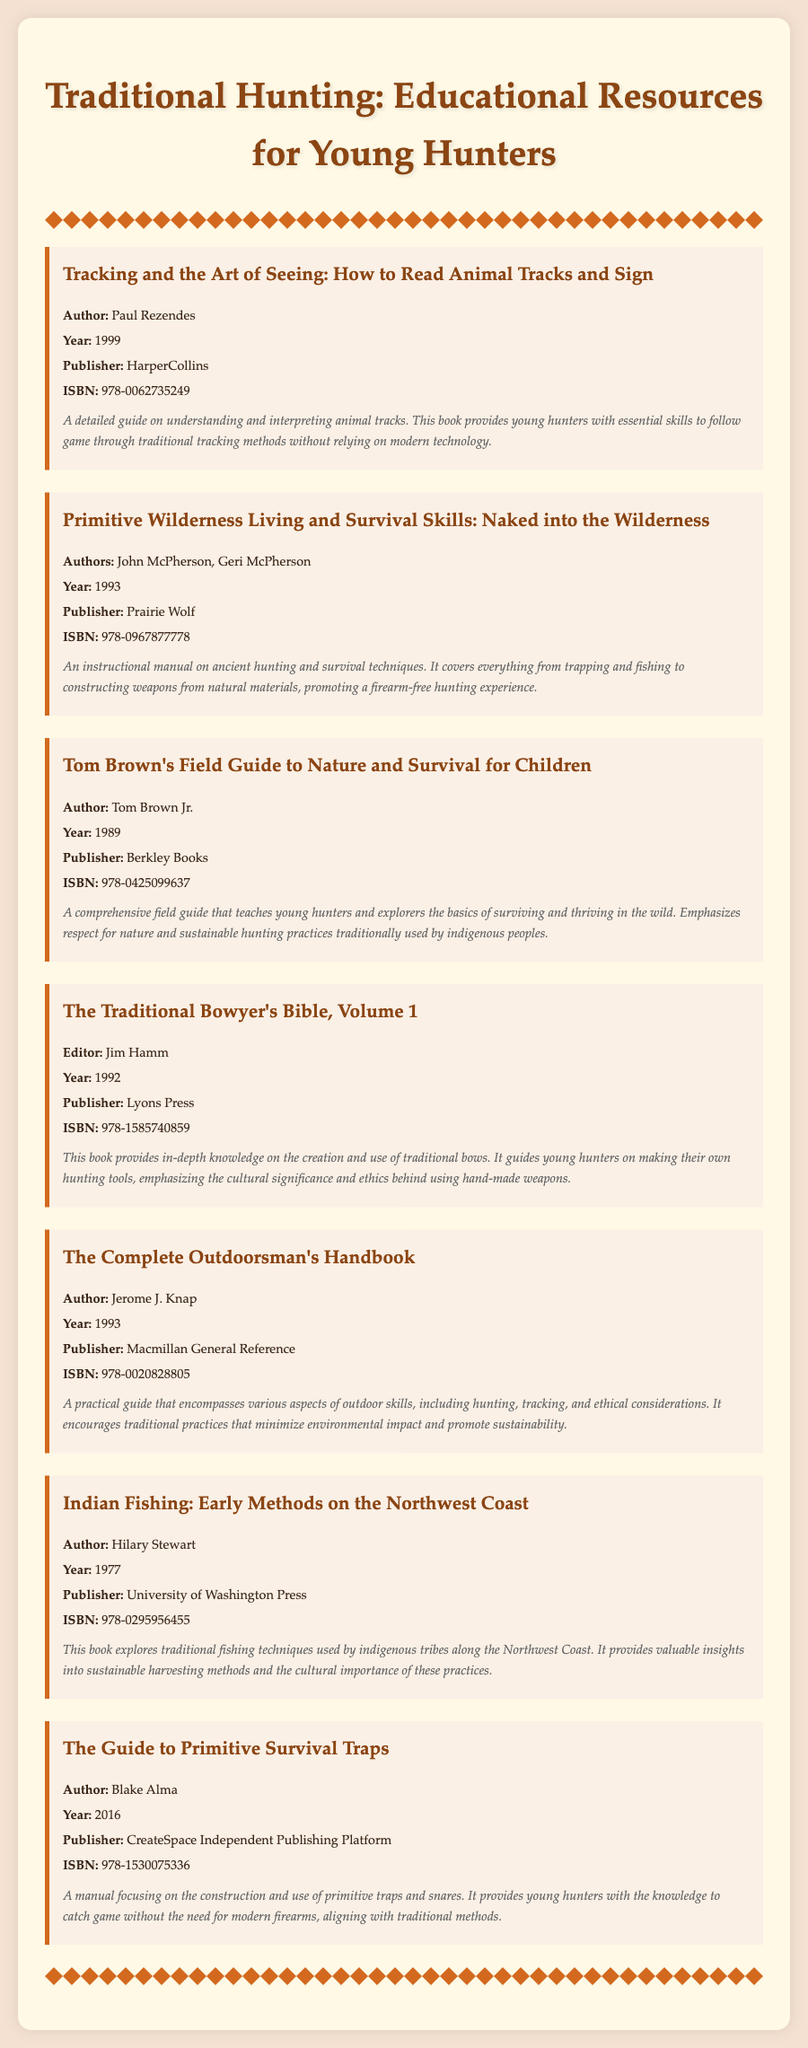What is the title of the first book listed? The title of the first book is found at the beginning of the document, which is "Tracking and the Art of Seeing: How to Read Animal Tracks and Sign."
Answer: Tracking and the Art of Seeing: How to Read Animal Tracks and Sign Who is the author of "Primitive Wilderness Living and Survival Skills"? The author can be identified in the document under the respective book section, where it mentions John McPherson and Geri McPherson.
Answer: John McPherson, Geri McPherson What year was "Tom Brown's Field Guide to Nature and Survival for Children" published? The publication year is explicitly mentioned in the book’s information in the document, which is 1989.
Answer: 1989 What is the ISBN of "The Traditional Bowyer's Bible, Volume 1"? The ISBN can be found in the bibliographic entry of the book, listed as 978-1585740859.
Answer: 978-1585740859 Which book focuses on fishing techniques? The book that focuses on fishing is specified in the document as "Indian Fishing: Early Methods on the Northwest Coast."
Answer: Indian Fishing: Early Methods on the Northwest Coast Which author emphasizes respect for nature? The emphasis on respect for nature is attributed to Tom Brown Jr. in his book description.
Answer: Tom Brown Jr What type of skills does "The Guide to Primitive Survival Traps" address? The document states that this book addresses the construction and use of primitive traps and snares.
Answer: Primitive trapping skills What is a key theme of the "Complete Outdoorsman's Handbook"? The handbook promotes traditional practices that minimize environmental impact and encourage sustainability, as mentioned in its description.
Answer: Sustainability and ethical practices 